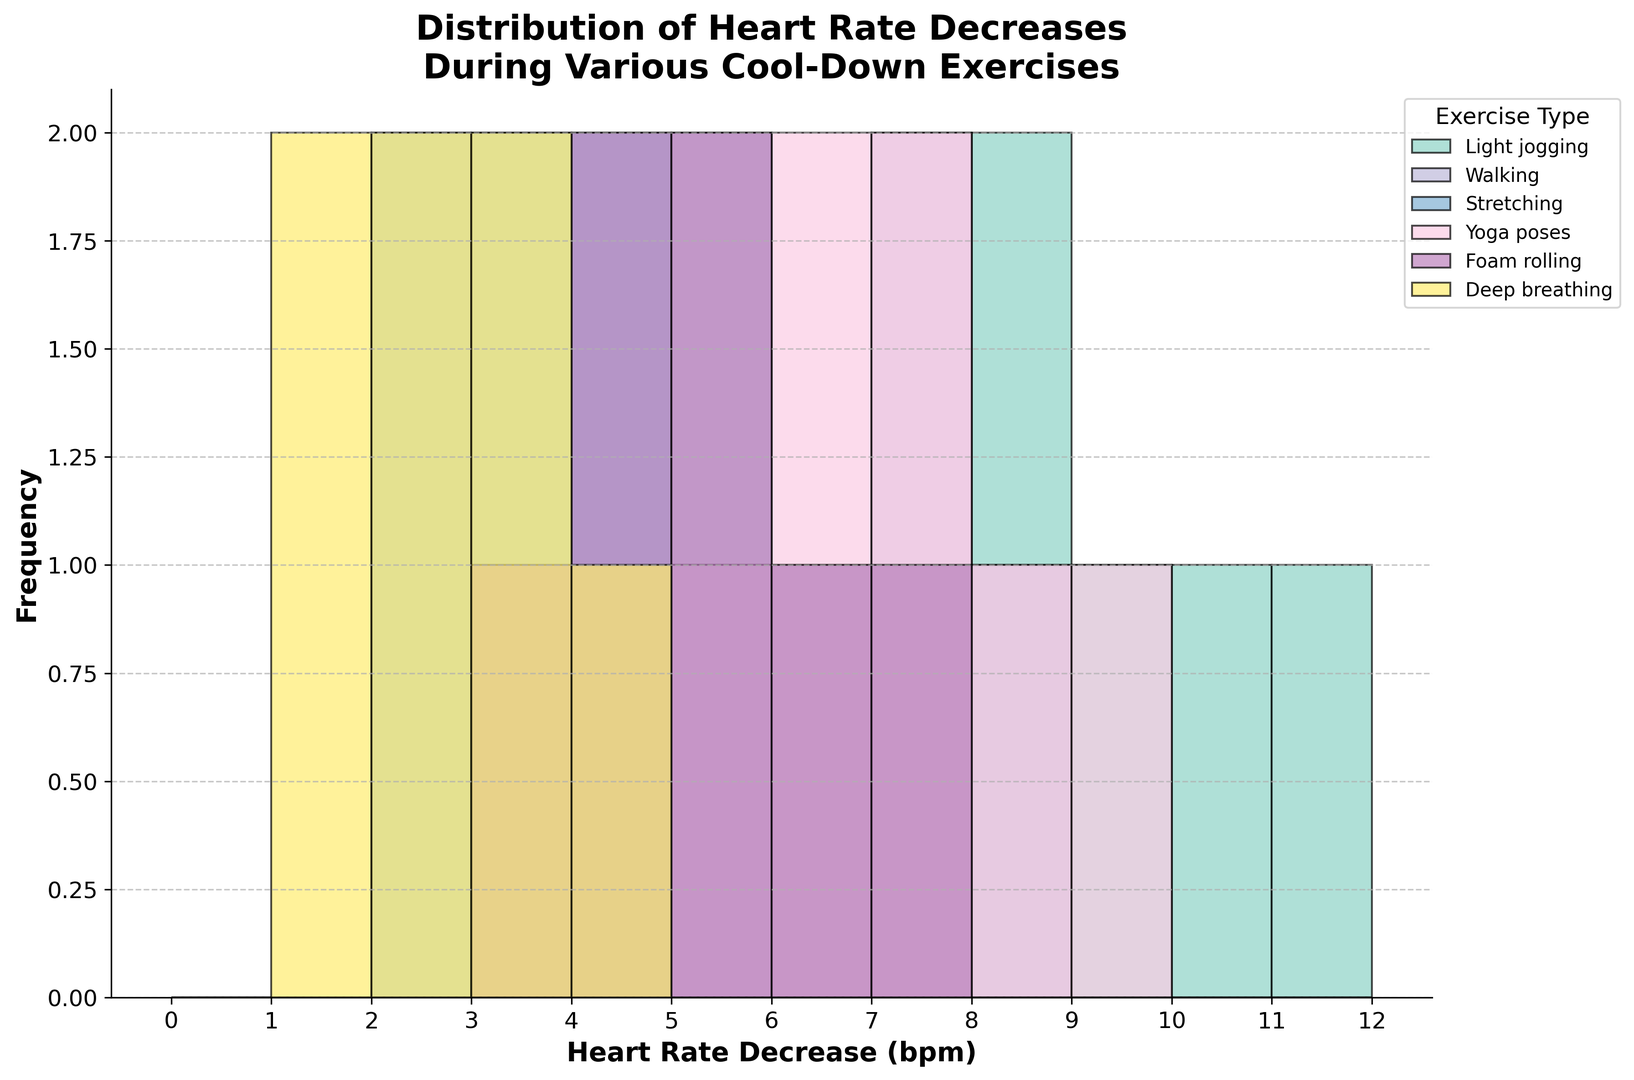What type of cool-down exercise shows the highest heart rate decrease? Look at the histogram and identify the exercise type with the highest frequency bar at the far right (higher heart rate decrease). Yoga poses have the highest peak around 9 bpm, which shows the highest heart rate decrease.
Answer: Yoga poses Which exercise has the most frequent heart rate decrease of 4 bpm? Examine the bars at the 4 bpm mark on the x-axis and notice which exercise has the highest frequency at that mark. Deep breathing and stretching have the tallest bars at 4 bpm. Therefore, both have the highest frequency.
Answer: Deep breathing, Stretching Are there any heart rate decreases that are common to all cool-down exercises? For this, check each bin along the x-axis and see if every exercise has a non-zero bar height at that bin. All exercises have a frequency greater than 0 at 4, 5, 6, and 7 bpm.
Answer: 4 bpm, 5 bpm, 6 bpm, 7 bpm What is the range of heart rate decreases for light jogging? Determine the smallest and largest values on the x-axis where there are visible bars for light jogging. Light jogging has bars from 6 bpm to 11 bpm.
Answer: 6 to 11 bpm Which exercise type has the smallest spread in heart rate decreases? Identify the exercise with the narrowest range between its smallest and largest bpm x-axis values. Stretching ranges from 2 to 5 bpm, which is the smallest spread.
Answer: Stretching How many heart rate decreases of 8 bpm were recorded for walking? Look at the height of the bar at the 8 bpm mark for walking. The histogram shows the frequency is 1 for walking at 8 bpm.
Answer: 1 What is the difference in the maximum heart rate decrease between deep breathing and foam rolling? Identify the highest bpm value for each exercise type and subtract the smaller from the larger. Foam rolling goes up to 7 bpm and deep breathing up to 4 bpm. The difference is 7 - 4 = 3 bpm.
Answer: 3 bpm What exercise is the least effective in decreasing heart rate, based on maximum heart rate decrease? Find the maximum bpm value for each exercise and identify the smallest one. Deep breathing has the lowest maximum heart rate decrease of 4 bpm.
Answer: Deep breathing Which exercise has the most uniform distribution of heart rate decreases? Observe the histograms and identify which exercise has bars of roughly equal height across its range. Walking has a relatively even distribution across several bpm values.
Answer: Walking 